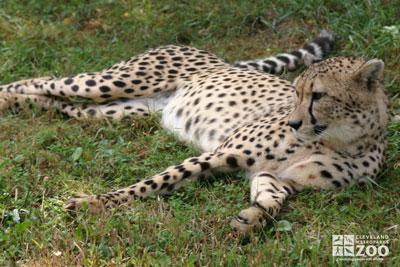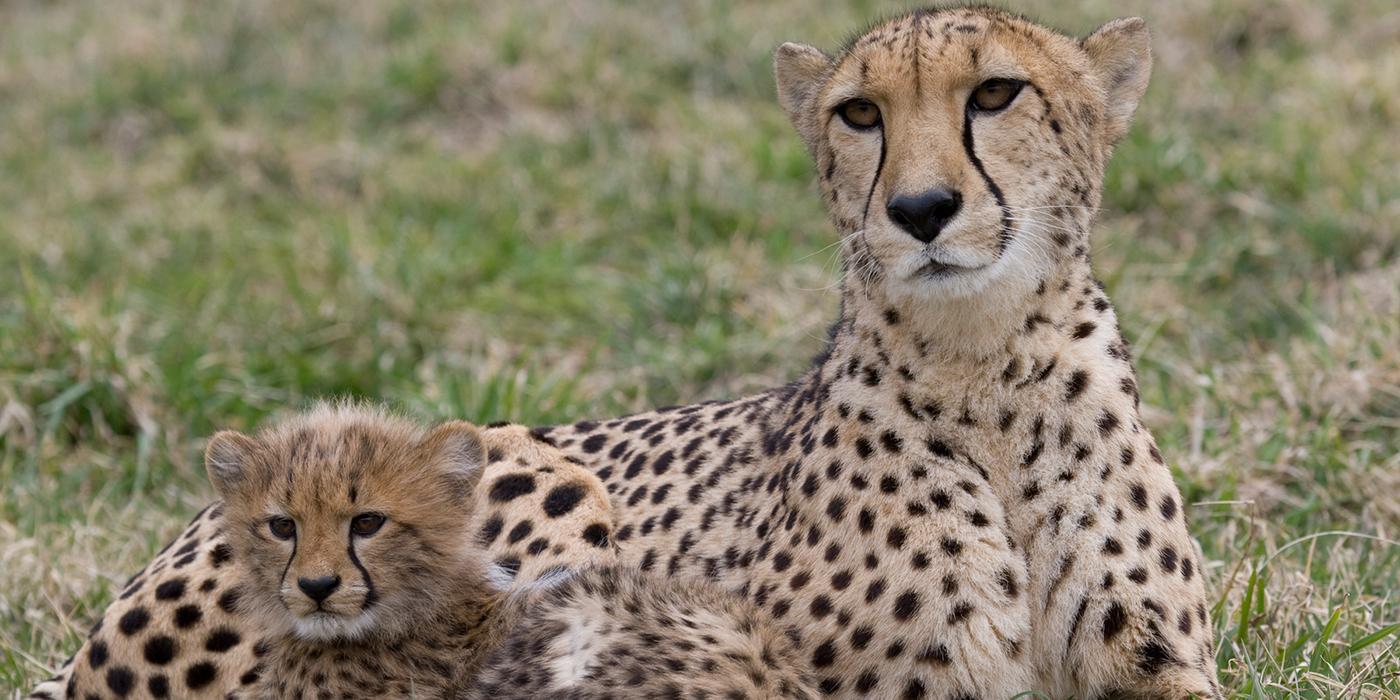The first image is the image on the left, the second image is the image on the right. Analyze the images presented: Is the assertion "The left image contains one cheetah, an adult lying on the ground, and the other image features a reclining adult cheetah with its head facing forward on the right, and a cheetah kitten in front of it with its head turned forward on the left." valid? Answer yes or no. Yes. The first image is the image on the left, the second image is the image on the right. For the images shown, is this caption "Three cats are lying down, with more in the image on the right." true? Answer yes or no. Yes. 